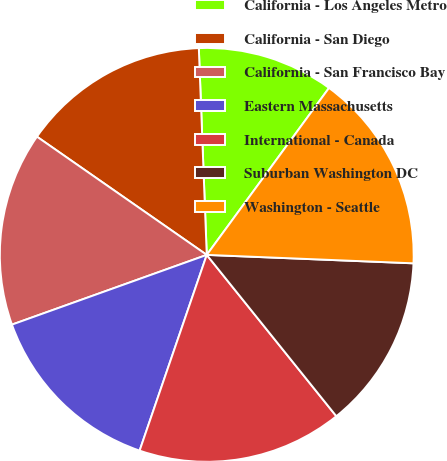<chart> <loc_0><loc_0><loc_500><loc_500><pie_chart><fcel>California - Los Angeles Metro<fcel>California - San Diego<fcel>California - San Francisco Bay<fcel>Eastern Massachusetts<fcel>International - Canada<fcel>Suburban Washington DC<fcel>Washington - Seattle<nl><fcel>10.67%<fcel>14.71%<fcel>15.15%<fcel>14.27%<fcel>16.03%<fcel>13.58%<fcel>15.59%<nl></chart> 